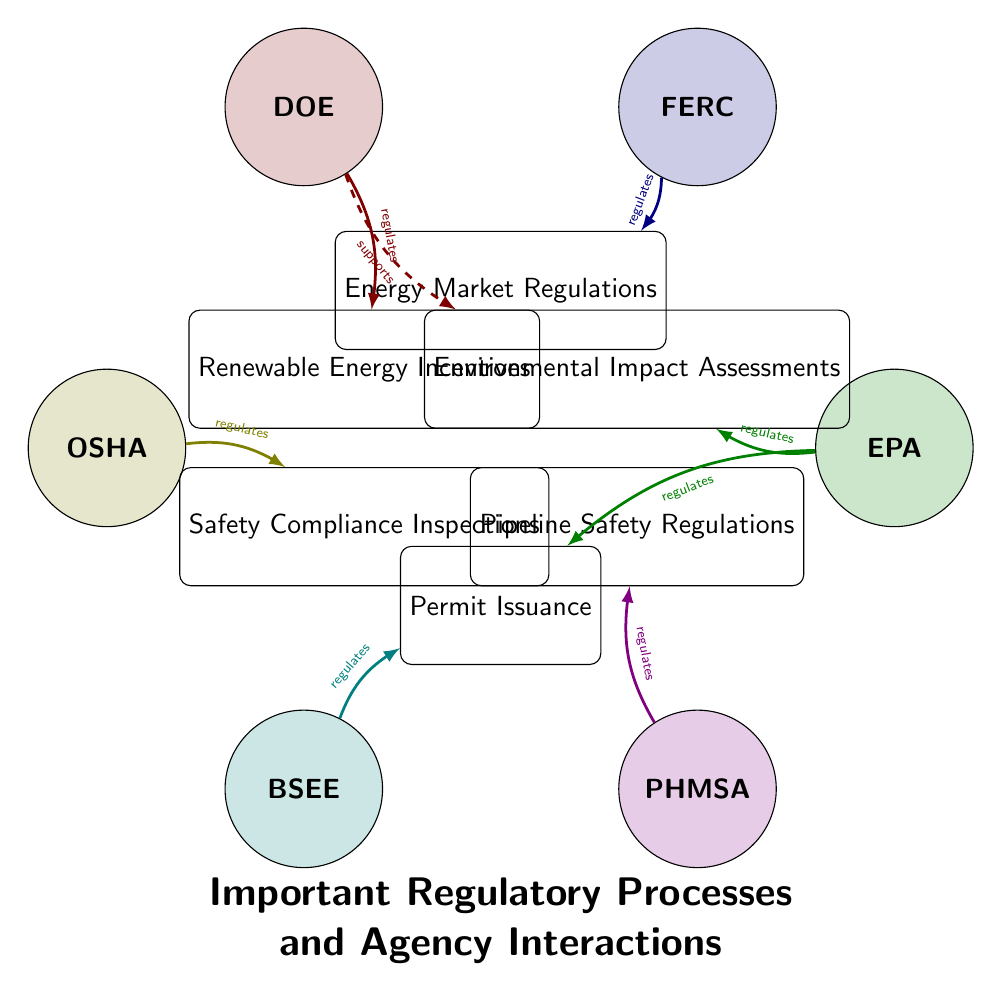What is the total number of regulatory agencies shown in the diagram? The diagram lists six regulatory agencies: EPA, FERC, DOE, OSHA, BSEE, and PHMSA. By counting each listed agency, we find that there are six in total.
Answer: 6 Which agency regulates Permit Issuance? The connections in the diagram indicate that both the BSEE and the EPA regulate Permit Issuance. The arrows directed towards the Permit Issuance node show this regulation relationship with both agencies.
Answer: BSEE, EPA How many processes are directly regulated by the DOE? The DOE regulates two processes as shown by the connections: Renewable Energy Incentives and is involved in supporting Environmental Impact Assessments. Thus, the count of the regulatory processes is two.
Answer: 2 Which agency supports Environmental Impact Assessments? Looking at the flow from the agencies to the processes, the DOE is the agency that supports Environmental Impact Assessments, as indicated by the dashed connection toward that process node.
Answer: DOE Which agency regulates Safety Compliance Inspections? Referring to the connections in the diagram, Safety Compliance Inspections are regulated by OSHA as shown by the directed arrow from OSHA to that process node.
Answer: OSHA What is the relationship type between PHMSA and Pipeline Safety Regulations? The connection shows that PHMSA regulates Pipeline Safety Regulations, indicated by the arrow and the label 'regulates' on the connection line.
Answer: regulates How many total direct interactions are shown in the diagram? By counting the connections from each regulatory agency to its corresponding processes, there are a total of seven direct interactions represented by arrows in the diagram.
Answer: 7 Explain the regulatory relationship between the EPA and Environmental Impact Assessments. According to the diagram, the EPA regulates Environmental Impact Assessments. This is depicted with a direct connection (arrow) from the EPA node to the Environmental Impact Assessments process node, indicating a regulatory authority.
Answer: regulates Which agency has the most interactions with regulatory processes? Reviewing the interactions, the EPA is linked to two processes, Permit Issuance and Environmental Impact Assessments. All others connect to only one except DOE with two connections. Therefore, the agency with the most interactions is the EPA.
Answer: EPA 